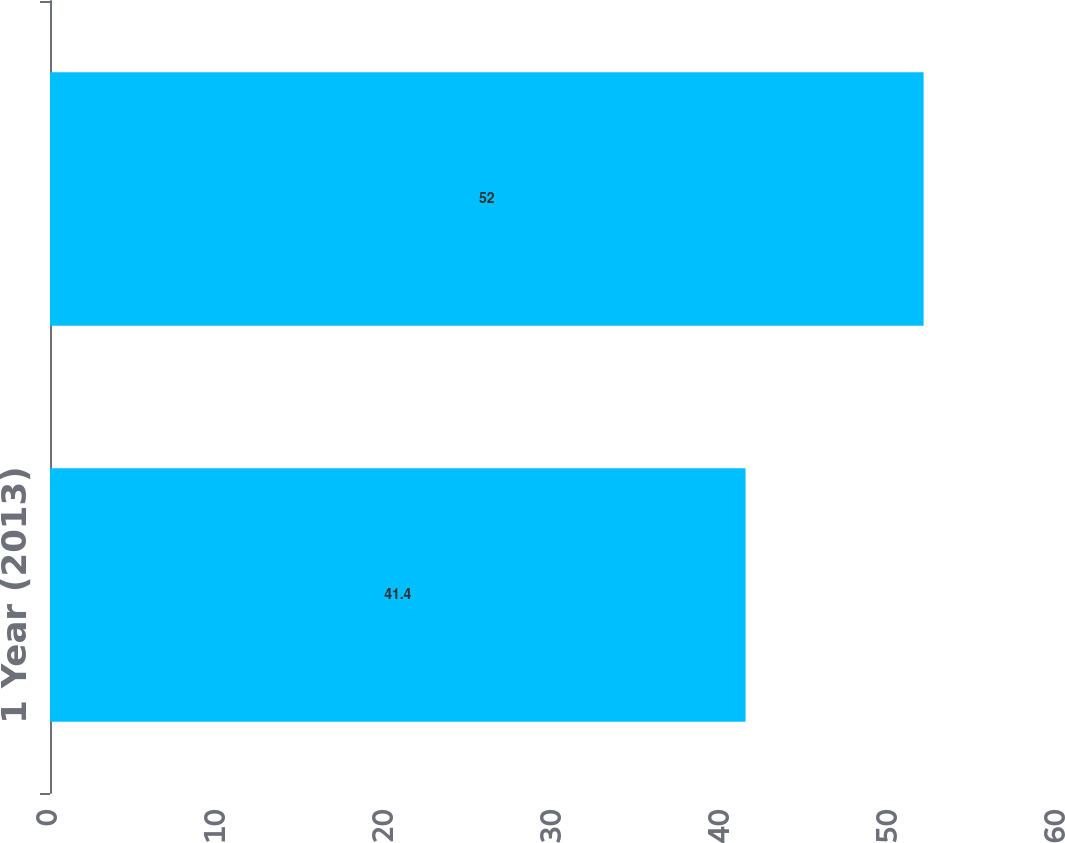<chart> <loc_0><loc_0><loc_500><loc_500><bar_chart><fcel>1 Year (2013)<fcel>3 Year (2011-2013)<nl><fcel>41.4<fcel>52<nl></chart> 